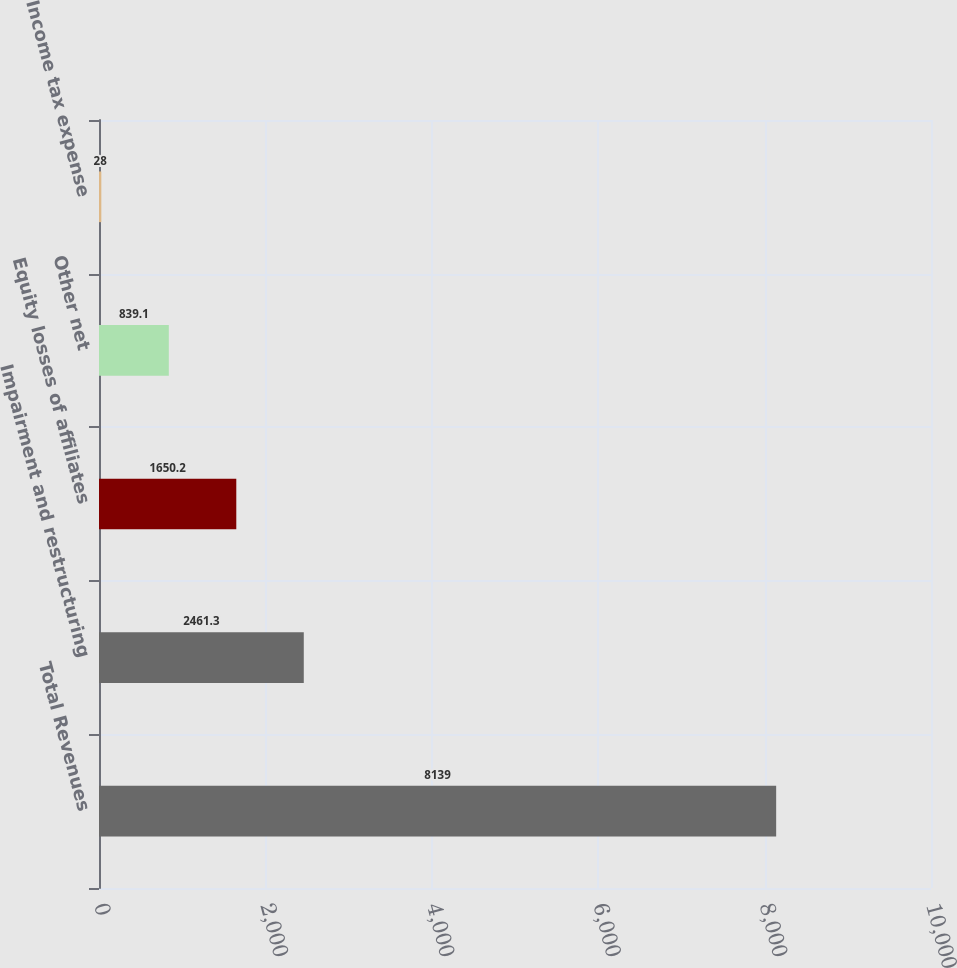Convert chart to OTSL. <chart><loc_0><loc_0><loc_500><loc_500><bar_chart><fcel>Total Revenues<fcel>Impairment and restructuring<fcel>Equity losses of affiliates<fcel>Other net<fcel>Income tax expense<nl><fcel>8139<fcel>2461.3<fcel>1650.2<fcel>839.1<fcel>28<nl></chart> 